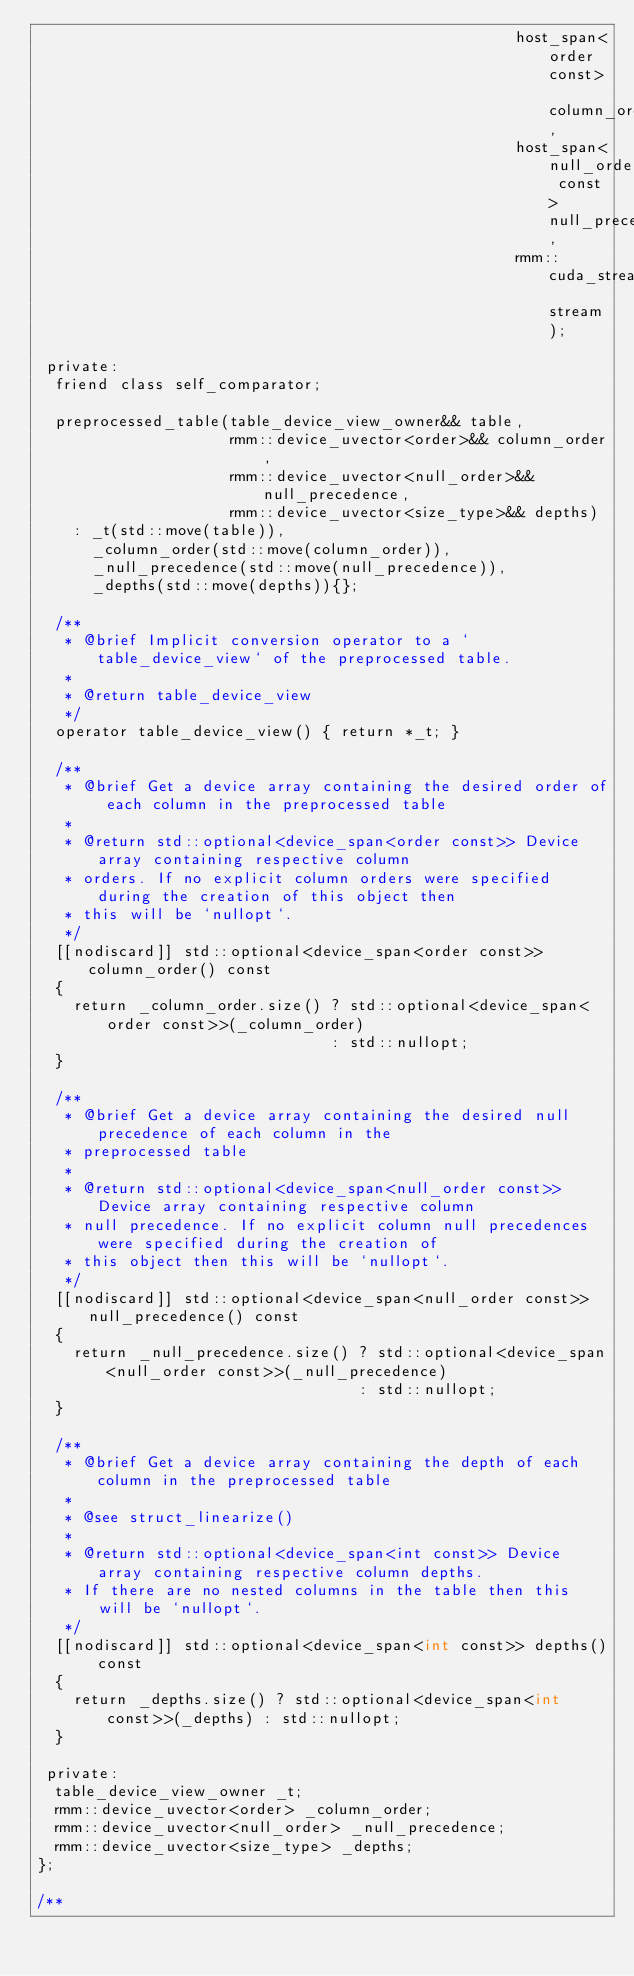<code> <loc_0><loc_0><loc_500><loc_500><_Cuda_>                                                    host_span<order const> column_order,
                                                    host_span<null_order const> null_precedence,
                                                    rmm::cuda_stream_view stream);

 private:
  friend class self_comparator;

  preprocessed_table(table_device_view_owner&& table,
                     rmm::device_uvector<order>&& column_order,
                     rmm::device_uvector<null_order>&& null_precedence,
                     rmm::device_uvector<size_type>&& depths)
    : _t(std::move(table)),
      _column_order(std::move(column_order)),
      _null_precedence(std::move(null_precedence)),
      _depths(std::move(depths)){};

  /**
   * @brief Implicit conversion operator to a `table_device_view` of the preprocessed table.
   *
   * @return table_device_view
   */
  operator table_device_view() { return *_t; }

  /**
   * @brief Get a device array containing the desired order of each column in the preprocessed table
   *
   * @return std::optional<device_span<order const>> Device array containing respective column
   * orders. If no explicit column orders were specified during the creation of this object then
   * this will be `nullopt`.
   */
  [[nodiscard]] std::optional<device_span<order const>> column_order() const
  {
    return _column_order.size() ? std::optional<device_span<order const>>(_column_order)
                                : std::nullopt;
  }

  /**
   * @brief Get a device array containing the desired null precedence of each column in the
   * preprocessed table
   *
   * @return std::optional<device_span<null_order const>> Device array containing respective column
   * null precedence. If no explicit column null precedences were specified during the creation of
   * this object then this will be `nullopt`.
   */
  [[nodiscard]] std::optional<device_span<null_order const>> null_precedence() const
  {
    return _null_precedence.size() ? std::optional<device_span<null_order const>>(_null_precedence)
                                   : std::nullopt;
  }

  /**
   * @brief Get a device array containing the depth of each column in the preprocessed table
   *
   * @see struct_linearize()
   *
   * @return std::optional<device_span<int const>> Device array containing respective column depths.
   * If there are no nested columns in the table then this will be `nullopt`.
   */
  [[nodiscard]] std::optional<device_span<int const>> depths() const
  {
    return _depths.size() ? std::optional<device_span<int const>>(_depths) : std::nullopt;
  }

 private:
  table_device_view_owner _t;
  rmm::device_uvector<order> _column_order;
  rmm::device_uvector<null_order> _null_precedence;
  rmm::device_uvector<size_type> _depths;
};

/**</code> 